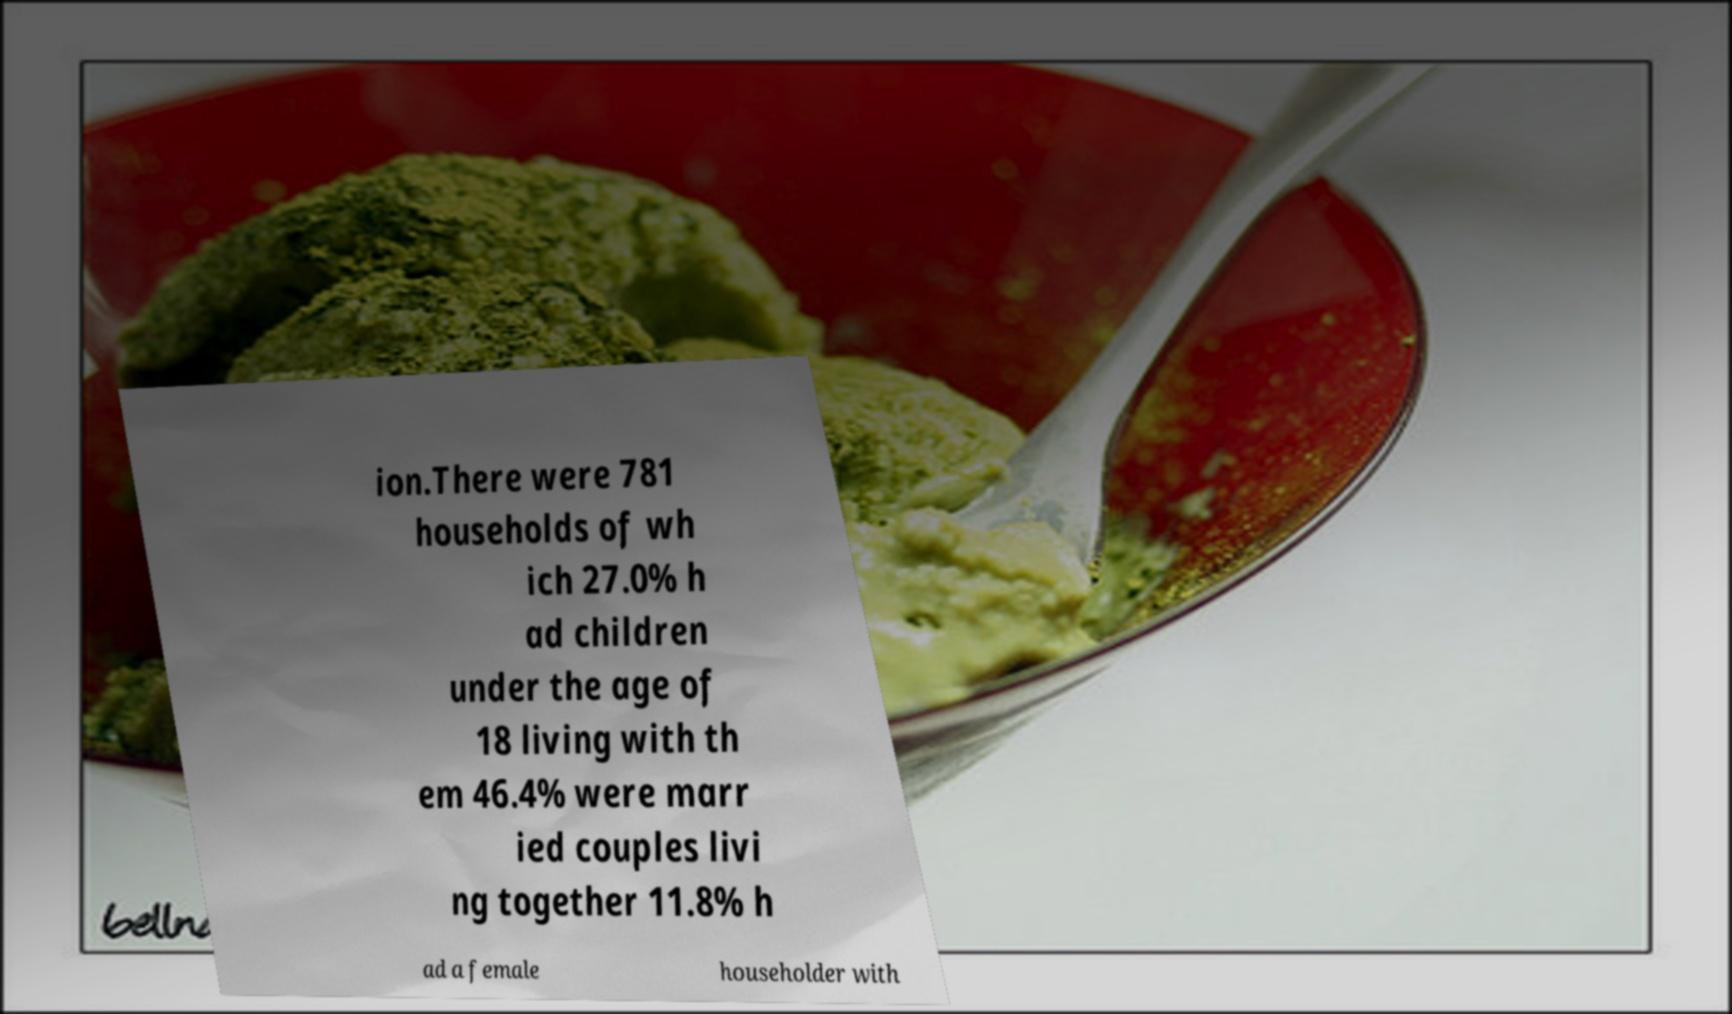Can you read and provide the text displayed in the image?This photo seems to have some interesting text. Can you extract and type it out for me? ion.There were 781 households of wh ich 27.0% h ad children under the age of 18 living with th em 46.4% were marr ied couples livi ng together 11.8% h ad a female householder with 